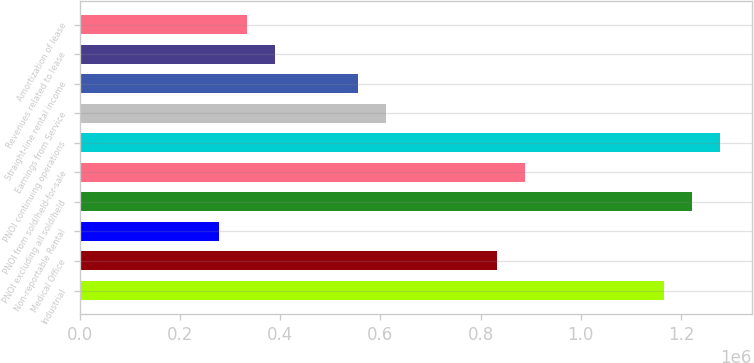<chart> <loc_0><loc_0><loc_500><loc_500><bar_chart><fcel>Industrial<fcel>Medical Office<fcel>Non-reportable Rental<fcel>PNOI excluding all sold/held<fcel>PNOI from sold/held-for-sale<fcel>PNOI continuing operations<fcel>Earnings from Service<fcel>Straight-line rental income<fcel>Revenues related to lease<fcel>Amortization of lease<nl><fcel>1.16693e+06<fcel>833605<fcel>278057<fcel>1.22249e+06<fcel>889160<fcel>1.27804e+06<fcel>611386<fcel>555831<fcel>389167<fcel>333612<nl></chart> 